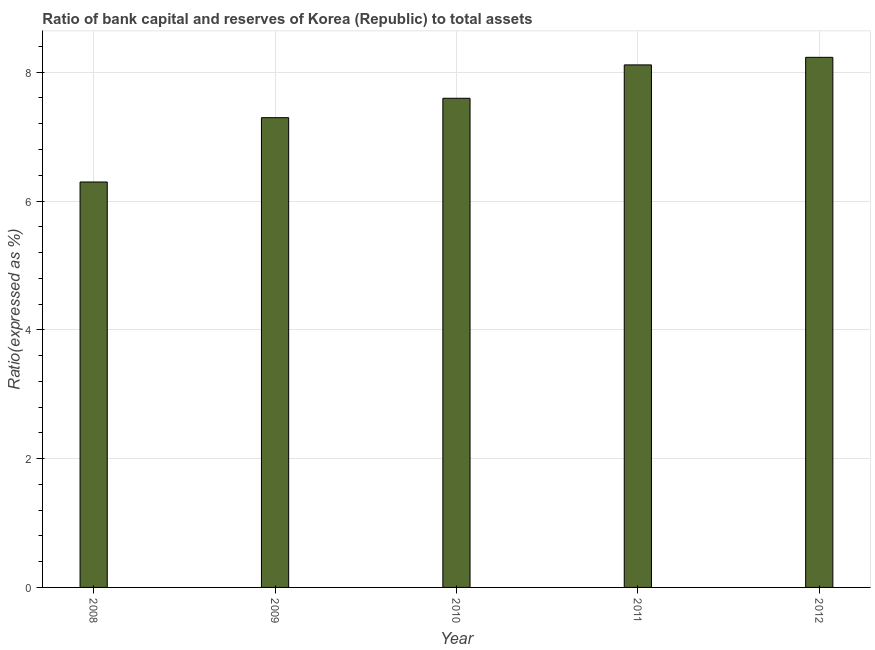Does the graph contain any zero values?
Your answer should be compact. No. What is the title of the graph?
Keep it short and to the point. Ratio of bank capital and reserves of Korea (Republic) to total assets. What is the label or title of the Y-axis?
Your response must be concise. Ratio(expressed as %). What is the bank capital to assets ratio in 2011?
Provide a short and direct response. 8.11. Across all years, what is the maximum bank capital to assets ratio?
Offer a terse response. 8.23. Across all years, what is the minimum bank capital to assets ratio?
Provide a succinct answer. 6.3. What is the sum of the bank capital to assets ratio?
Your response must be concise. 37.53. What is the difference between the bank capital to assets ratio in 2011 and 2012?
Your answer should be very brief. -0.12. What is the average bank capital to assets ratio per year?
Your answer should be compact. 7.51. What is the median bank capital to assets ratio?
Provide a short and direct response. 7.6. In how many years, is the bank capital to assets ratio greater than 6 %?
Offer a terse response. 5. Do a majority of the years between 2009 and 2010 (inclusive) have bank capital to assets ratio greater than 7.6 %?
Offer a terse response. No. What is the ratio of the bank capital to assets ratio in 2008 to that in 2009?
Your answer should be compact. 0.86. Is the difference between the bank capital to assets ratio in 2008 and 2010 greater than the difference between any two years?
Your answer should be compact. No. What is the difference between the highest and the second highest bank capital to assets ratio?
Make the answer very short. 0.12. Is the sum of the bank capital to assets ratio in 2008 and 2012 greater than the maximum bank capital to assets ratio across all years?
Make the answer very short. Yes. What is the difference between the highest and the lowest bank capital to assets ratio?
Offer a terse response. 1.94. In how many years, is the bank capital to assets ratio greater than the average bank capital to assets ratio taken over all years?
Keep it short and to the point. 3. How many bars are there?
Ensure brevity in your answer.  5. Are all the bars in the graph horizontal?
Your answer should be compact. No. How many years are there in the graph?
Provide a short and direct response. 5. Are the values on the major ticks of Y-axis written in scientific E-notation?
Ensure brevity in your answer.  No. What is the Ratio(expressed as %) of 2008?
Make the answer very short. 6.3. What is the Ratio(expressed as %) in 2009?
Your answer should be very brief. 7.29. What is the Ratio(expressed as %) of 2010?
Provide a short and direct response. 7.6. What is the Ratio(expressed as %) in 2011?
Give a very brief answer. 8.11. What is the Ratio(expressed as %) in 2012?
Your answer should be compact. 8.23. What is the difference between the Ratio(expressed as %) in 2008 and 2009?
Provide a short and direct response. -1. What is the difference between the Ratio(expressed as %) in 2008 and 2010?
Provide a succinct answer. -1.3. What is the difference between the Ratio(expressed as %) in 2008 and 2011?
Your answer should be compact. -1.82. What is the difference between the Ratio(expressed as %) in 2008 and 2012?
Keep it short and to the point. -1.94. What is the difference between the Ratio(expressed as %) in 2009 and 2010?
Make the answer very short. -0.3. What is the difference between the Ratio(expressed as %) in 2009 and 2011?
Make the answer very short. -0.82. What is the difference between the Ratio(expressed as %) in 2009 and 2012?
Your answer should be very brief. -0.94. What is the difference between the Ratio(expressed as %) in 2010 and 2011?
Ensure brevity in your answer.  -0.52. What is the difference between the Ratio(expressed as %) in 2010 and 2012?
Offer a terse response. -0.64. What is the difference between the Ratio(expressed as %) in 2011 and 2012?
Provide a succinct answer. -0.12. What is the ratio of the Ratio(expressed as %) in 2008 to that in 2009?
Provide a succinct answer. 0.86. What is the ratio of the Ratio(expressed as %) in 2008 to that in 2010?
Ensure brevity in your answer.  0.83. What is the ratio of the Ratio(expressed as %) in 2008 to that in 2011?
Give a very brief answer. 0.78. What is the ratio of the Ratio(expressed as %) in 2008 to that in 2012?
Offer a terse response. 0.77. What is the ratio of the Ratio(expressed as %) in 2009 to that in 2011?
Your answer should be compact. 0.9. What is the ratio of the Ratio(expressed as %) in 2009 to that in 2012?
Offer a terse response. 0.89. What is the ratio of the Ratio(expressed as %) in 2010 to that in 2011?
Offer a very short reply. 0.94. What is the ratio of the Ratio(expressed as %) in 2010 to that in 2012?
Your answer should be compact. 0.92. 